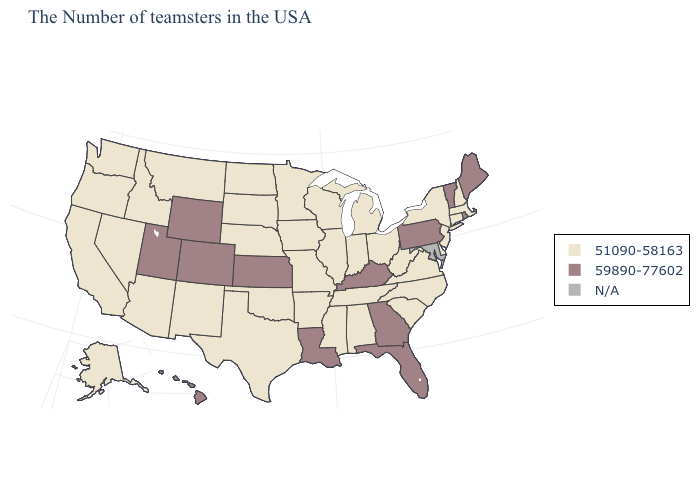What is the highest value in the MidWest ?
Write a very short answer. 59890-77602. What is the value of Georgia?
Concise answer only. 59890-77602. Does Rhode Island have the highest value in the USA?
Write a very short answer. Yes. Which states have the lowest value in the USA?
Concise answer only. Massachusetts, New Hampshire, Connecticut, New York, New Jersey, Delaware, Virginia, North Carolina, South Carolina, West Virginia, Ohio, Michigan, Indiana, Alabama, Tennessee, Wisconsin, Illinois, Mississippi, Missouri, Arkansas, Minnesota, Iowa, Nebraska, Oklahoma, Texas, South Dakota, North Dakota, New Mexico, Montana, Arizona, Idaho, Nevada, California, Washington, Oregon, Alaska. Does the map have missing data?
Answer briefly. Yes. Name the states that have a value in the range 51090-58163?
Give a very brief answer. Massachusetts, New Hampshire, Connecticut, New York, New Jersey, Delaware, Virginia, North Carolina, South Carolina, West Virginia, Ohio, Michigan, Indiana, Alabama, Tennessee, Wisconsin, Illinois, Mississippi, Missouri, Arkansas, Minnesota, Iowa, Nebraska, Oklahoma, Texas, South Dakota, North Dakota, New Mexico, Montana, Arizona, Idaho, Nevada, California, Washington, Oregon, Alaska. What is the highest value in the Northeast ?
Be succinct. 59890-77602. What is the lowest value in the USA?
Write a very short answer. 51090-58163. Among the states that border Nebraska , does South Dakota have the highest value?
Short answer required. No. Among the states that border Georgia , which have the highest value?
Be succinct. Florida. What is the highest value in the USA?
Give a very brief answer. 59890-77602. Name the states that have a value in the range N/A?
Keep it brief. Maryland. What is the lowest value in the West?
Be succinct. 51090-58163. 